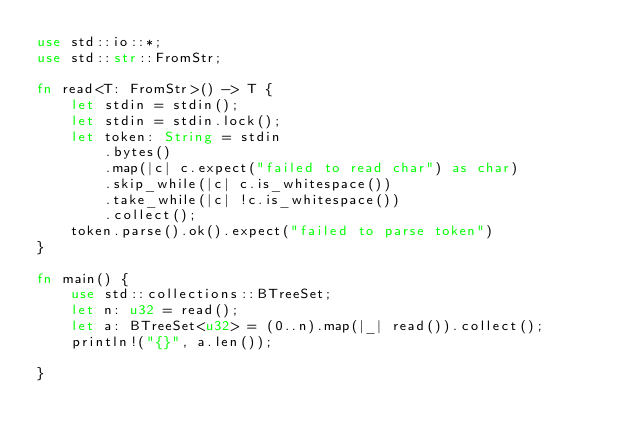<code> <loc_0><loc_0><loc_500><loc_500><_Rust_>use std::io::*;
use std::str::FromStr;

fn read<T: FromStr>() -> T {
    let stdin = stdin();
    let stdin = stdin.lock();
    let token: String = stdin
        .bytes()
        .map(|c| c.expect("failed to read char") as char)
        .skip_while(|c| c.is_whitespace())
        .take_while(|c| !c.is_whitespace())
        .collect();
    token.parse().ok().expect("failed to parse token")
}

fn main() {
    use std::collections::BTreeSet;
    let n: u32 = read();
    let a: BTreeSet<u32> = (0..n).map(|_| read()).collect();
    println!("{}", a.len());

}
</code> 